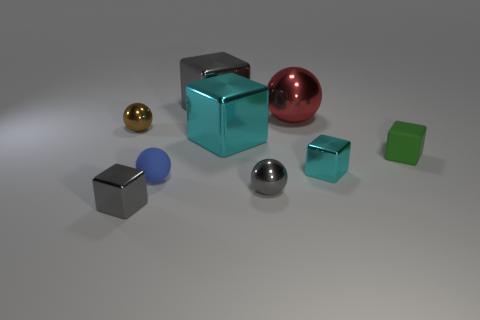What shape is the brown object that is the same size as the green matte thing?
Provide a succinct answer. Sphere. What number of objects are small brown shiny things to the left of the blue matte ball or small rubber cubes?
Ensure brevity in your answer.  2. Is the rubber sphere the same color as the large metal sphere?
Keep it short and to the point. No. What is the size of the cyan metallic block left of the small gray metal ball?
Offer a very short reply. Large. Is there a cyan shiny cube of the same size as the brown shiny ball?
Make the answer very short. Yes. Do the rubber thing on the left side of the rubber cube and the large red thing have the same size?
Ensure brevity in your answer.  No. How big is the red thing?
Ensure brevity in your answer.  Large. There is a large object that is on the right side of the tiny ball that is right of the thing that is behind the red object; what is its color?
Provide a succinct answer. Red. There is a tiny sphere behind the large cyan metallic object; is it the same color as the small rubber cube?
Offer a terse response. No. What number of things are both left of the tiny green rubber object and on the right side of the blue ball?
Provide a succinct answer. 5. 